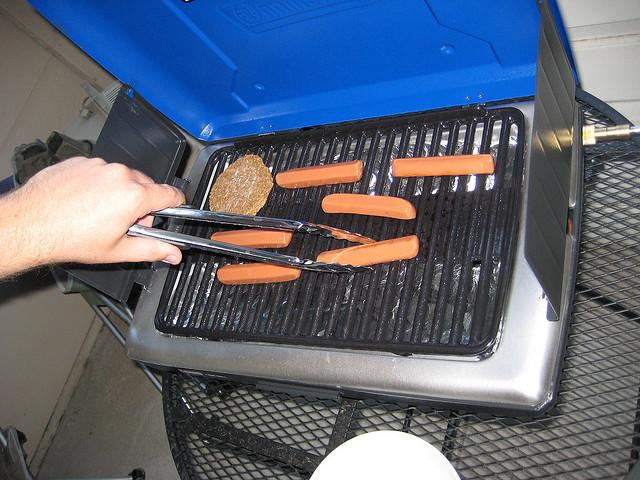Is this a vegan meal?
Write a very short answer. No. If you closed your eyes and reached, is there a 75 or more percent chance you'd get a hot dog?
Give a very brief answer. Yes. Is someone grilling sausages?
Quick response, please. Yes. 